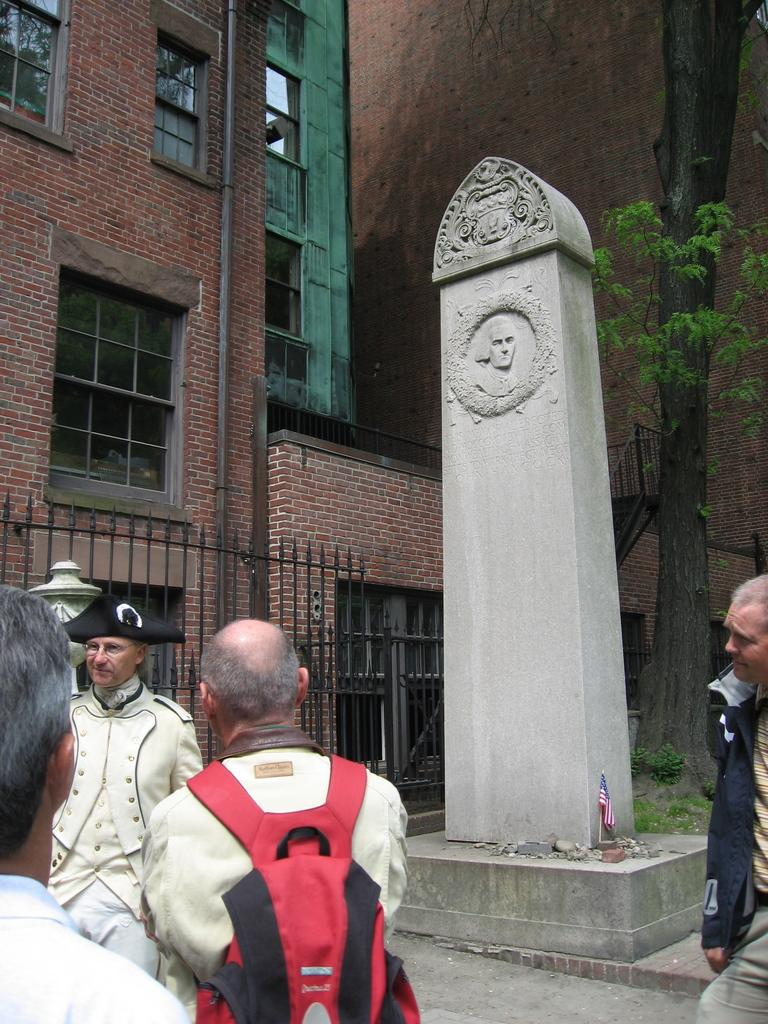How many people are in the image? There are people in the image, but the exact number is not specified. What is one person wearing in the image? One person is wearing a bag in the image. What can be seen in the background of the image? In the background of the image, there are stone, buildings, and trees. What type of seed is being used by the band in the image? There is no band or seed present in the image. What kind of apparatus is being used by the people in the image? The facts provided do not mention any specific apparatus being used by the people in the image. 